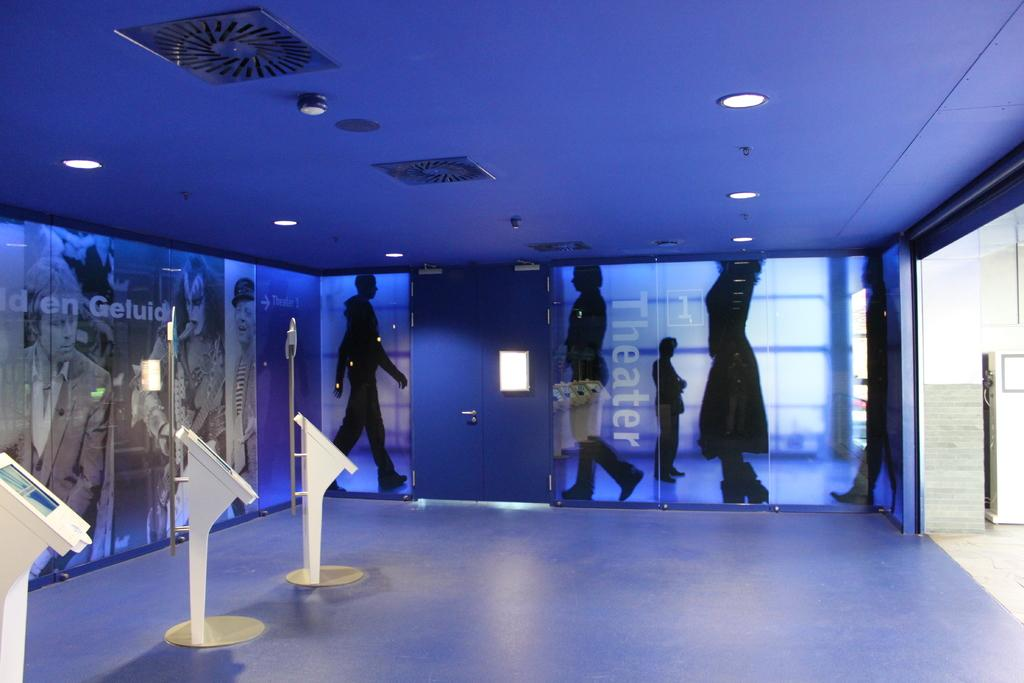What is the main object in the image? There is a door in the image. Are there any additional features visible in the image? Yes, there are lights on the wall at the top of the image. What type of growth can be seen on the door in the image? There is no growth visible on the door in the image. What calendar is hanging on the wall next to the door? There is no calendar present in the image; only the door and lights on the wall are visible. 